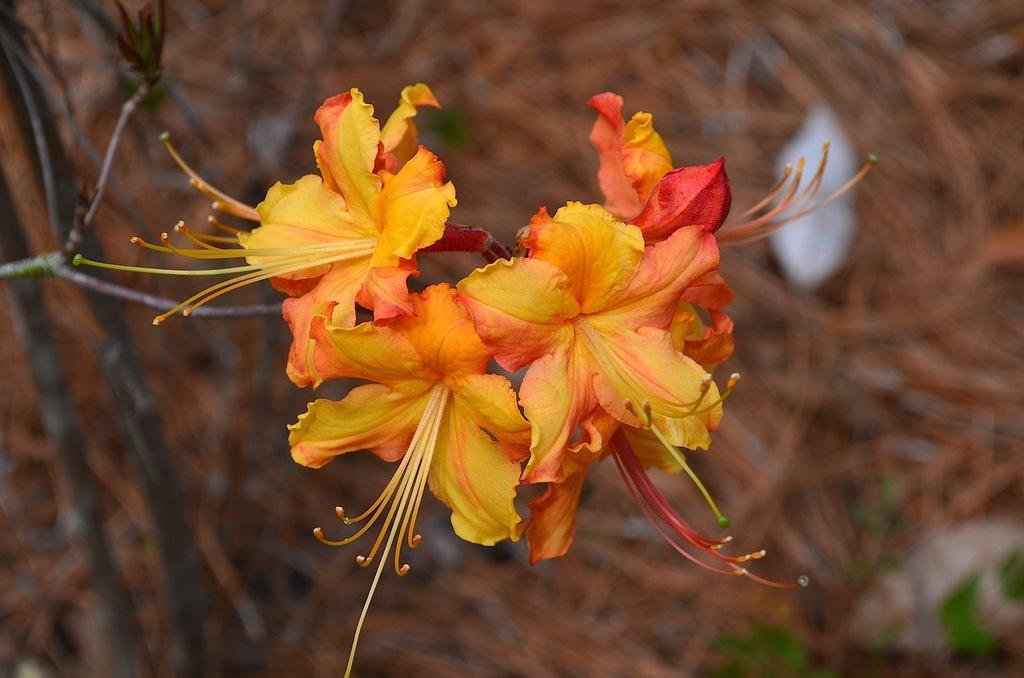What type of plants can be seen in the image? There are flowers in the image. What color are the flowers? The flowers are yellow. What can be found on the flowers in the image? Pollen grains are present in the image. How would you describe the background of the image? The background of the image is blurred. What type of argument is taking place between the flowers in the image? There is no argument taking place between the flowers in the image, as flowers do not engage in arguments. 